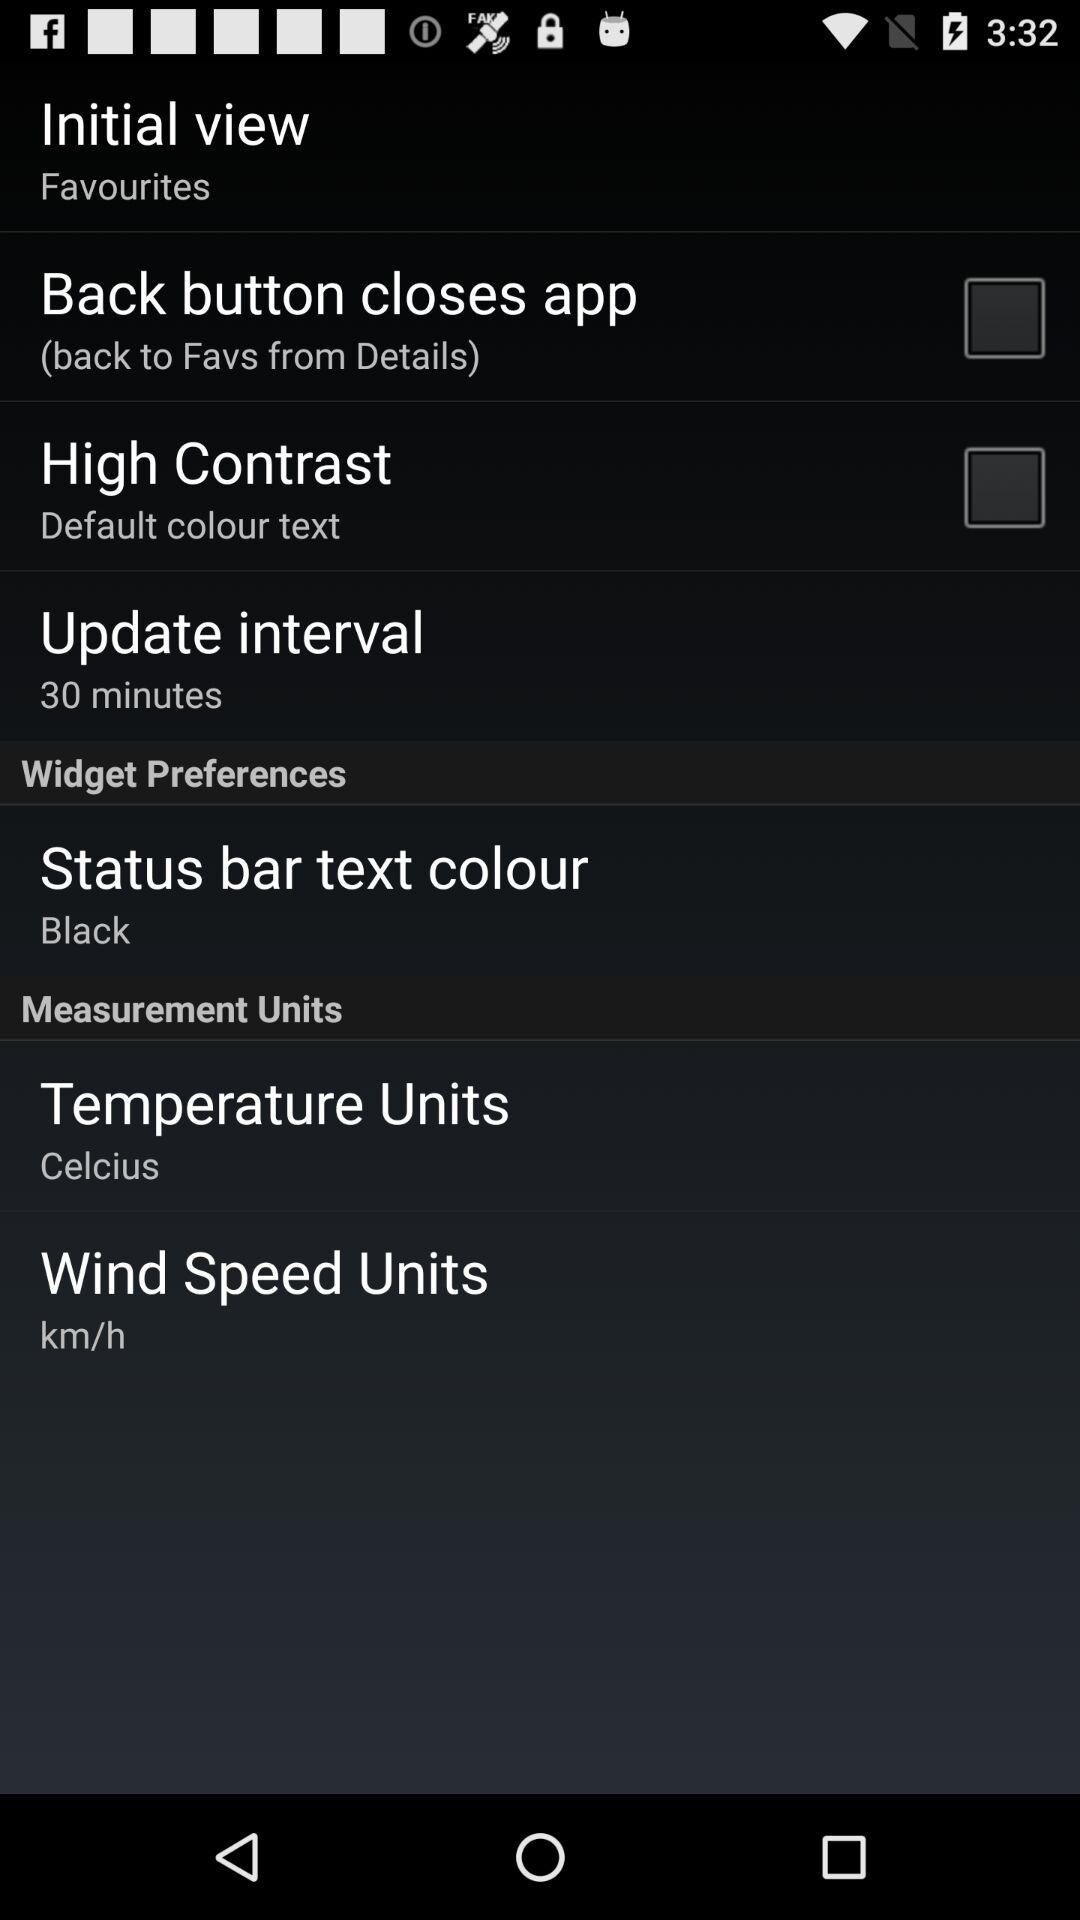What's the temperature unit? The temperature unit is Celsius. 